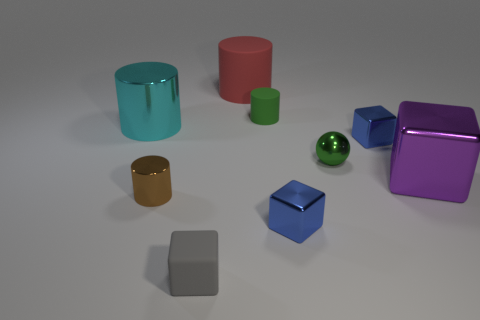There is a big red matte thing; is its shape the same as the large metal object right of the gray object?
Keep it short and to the point. No. How many other objects are the same size as the green rubber object?
Provide a short and direct response. 5. Is the number of gray things greater than the number of tiny green shiny cylinders?
Offer a very short reply. Yes. What number of metallic objects are both in front of the large cube and left of the rubber block?
Your answer should be very brief. 1. What is the shape of the small green thing in front of the metallic cylinder that is to the left of the tiny metal thing that is left of the red cylinder?
Offer a terse response. Sphere. Are there any other things that are the same shape as the gray rubber thing?
Provide a short and direct response. Yes. What number of balls are small objects or red matte things?
Your answer should be very brief. 1. There is a large metal object that is to the left of the large purple object; does it have the same color as the matte block?
Make the answer very short. No. The big cylinder right of the big thing that is to the left of the small rubber thing that is in front of the green cylinder is made of what material?
Keep it short and to the point. Rubber. Do the gray thing and the green cylinder have the same size?
Your response must be concise. Yes. 